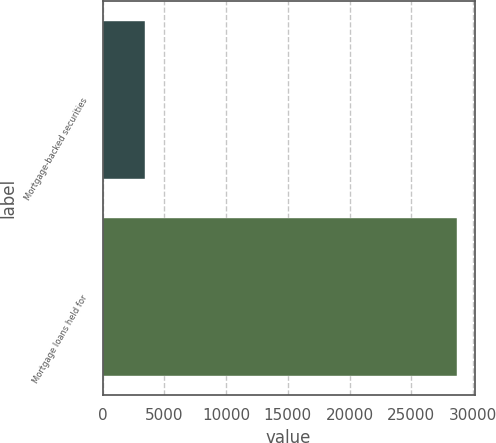<chart> <loc_0><loc_0><loc_500><loc_500><bar_chart><fcel>Mortgage-backed securities<fcel>Mortgage loans held for<nl><fcel>3450<fcel>28689<nl></chart> 